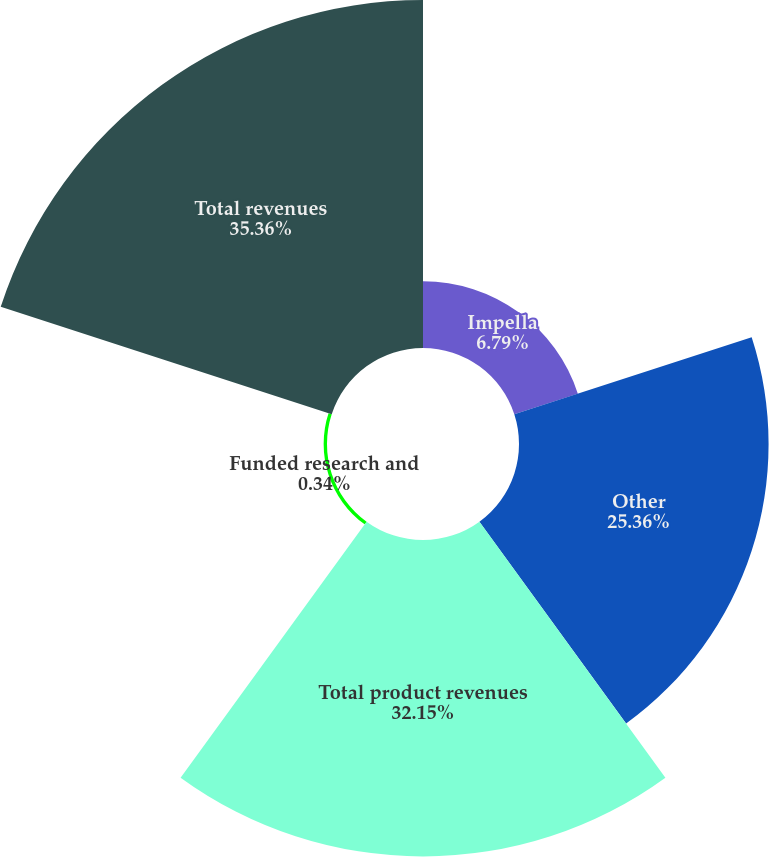Convert chart to OTSL. <chart><loc_0><loc_0><loc_500><loc_500><pie_chart><fcel>Impella<fcel>Other<fcel>Total product revenues<fcel>Funded research and<fcel>Total revenues<nl><fcel>6.79%<fcel>25.36%<fcel>32.15%<fcel>0.34%<fcel>35.36%<nl></chart> 